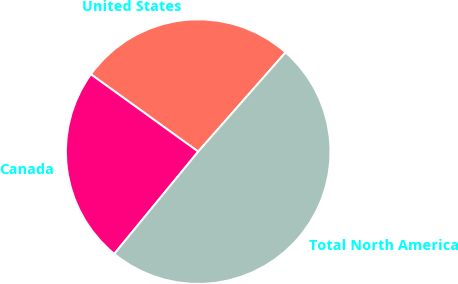Convert chart to OTSL. <chart><loc_0><loc_0><loc_500><loc_500><pie_chart><fcel>United States<fcel>Canada<fcel>Total North America<nl><fcel>26.55%<fcel>24.0%<fcel>49.45%<nl></chart> 